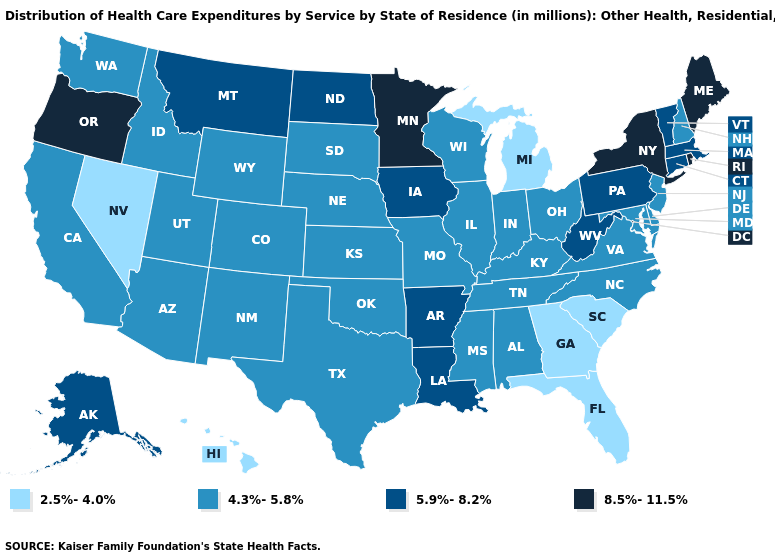Among the states that border Tennessee , which have the lowest value?
Give a very brief answer. Georgia. What is the highest value in the USA?
Be succinct. 8.5%-11.5%. Does Wyoming have the lowest value in the USA?
Quick response, please. No. What is the value of Nebraska?
Write a very short answer. 4.3%-5.8%. Among the states that border North Dakota , which have the lowest value?
Quick response, please. South Dakota. What is the highest value in the USA?
Quick response, please. 8.5%-11.5%. Which states have the highest value in the USA?
Concise answer only. Maine, Minnesota, New York, Oregon, Rhode Island. What is the value of New Jersey?
Give a very brief answer. 4.3%-5.8%. Does Massachusetts have the highest value in the Northeast?
Answer briefly. No. Which states have the lowest value in the USA?
Short answer required. Florida, Georgia, Hawaii, Michigan, Nevada, South Carolina. What is the value of Nebraska?
Be succinct. 4.3%-5.8%. Which states have the lowest value in the USA?
Be succinct. Florida, Georgia, Hawaii, Michigan, Nevada, South Carolina. What is the lowest value in the MidWest?
Short answer required. 2.5%-4.0%. What is the value of Arizona?
Quick response, please. 4.3%-5.8%. 